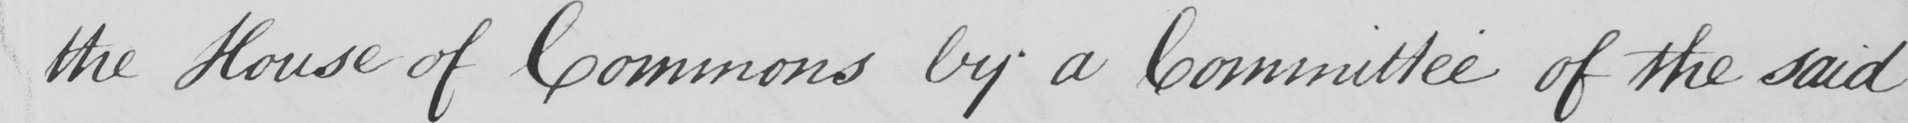What does this handwritten line say? the House of Commons by a Committee of the said 